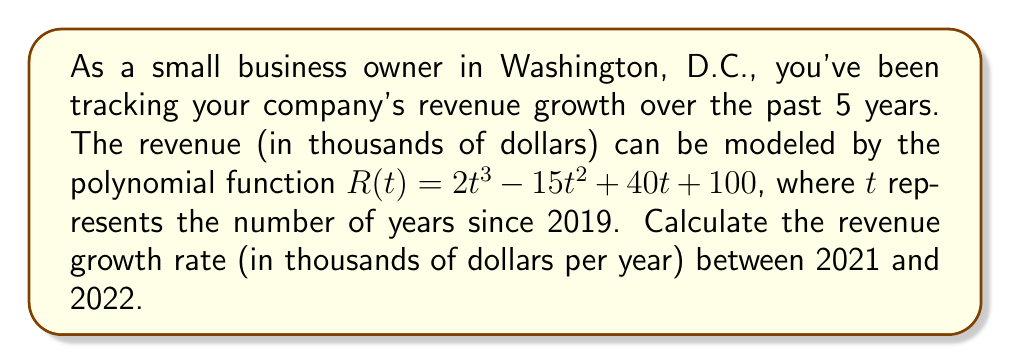Provide a solution to this math problem. To solve this problem, we'll follow these steps:

1) The revenue growth rate is the derivative of the revenue function. Let's find $R'(t)$:
   $$R'(t) = 6t^2 - 30t + 40$$

2) We need to calculate the growth rate between 2021 and 2022. These correspond to $t = 2$ and $t = 3$ respectively.

3) Calculate $R'(2)$:
   $$R'(2) = 6(2)^2 - 30(2) + 40 = 24 - 60 + 40 = 4$$

4) Calculate $R'(3)$:
   $$R'(3) = 6(3)^2 - 30(3) + 40 = 54 - 90 + 40 = 4$$

5) The growth rate between 2021 and 2022 is the average of these two values:
   $$\text{Growth Rate} = \frac{R'(2) + R'(3)}{2} = \frac{4 + 4}{2} = 4$$

Therefore, the revenue growth rate between 2021 and 2022 is 4 thousand dollars per year.
Answer: $4$ thousand dollars per year 